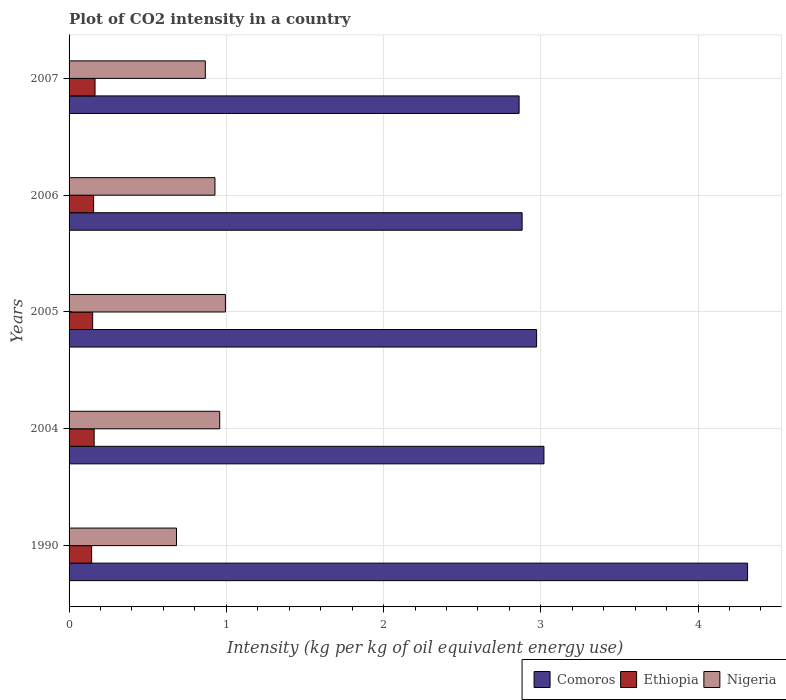How many different coloured bars are there?
Keep it short and to the point. 3. How many groups of bars are there?
Give a very brief answer. 5. Are the number of bars on each tick of the Y-axis equal?
Your answer should be compact. Yes. How many bars are there on the 1st tick from the top?
Your answer should be very brief. 3. How many bars are there on the 1st tick from the bottom?
Your answer should be compact. 3. In how many cases, is the number of bars for a given year not equal to the number of legend labels?
Keep it short and to the point. 0. What is the CO2 intensity in in Nigeria in 1990?
Provide a short and direct response. 0.68. Across all years, what is the maximum CO2 intensity in in Nigeria?
Offer a terse response. 0.99. Across all years, what is the minimum CO2 intensity in in Comoros?
Your answer should be compact. 2.86. In which year was the CO2 intensity in in Ethiopia maximum?
Give a very brief answer. 2007. What is the total CO2 intensity in in Comoros in the graph?
Make the answer very short. 16.05. What is the difference between the CO2 intensity in in Ethiopia in 1990 and that in 2006?
Your answer should be very brief. -0.01. What is the difference between the CO2 intensity in in Nigeria in 1990 and the CO2 intensity in in Ethiopia in 2005?
Provide a short and direct response. 0.53. What is the average CO2 intensity in in Ethiopia per year?
Make the answer very short. 0.15. In the year 2005, what is the difference between the CO2 intensity in in Nigeria and CO2 intensity in in Comoros?
Offer a very short reply. -1.98. In how many years, is the CO2 intensity in in Nigeria greater than 1 kg?
Provide a succinct answer. 0. What is the ratio of the CO2 intensity in in Comoros in 1990 to that in 2007?
Your response must be concise. 1.51. Is the difference between the CO2 intensity in in Nigeria in 1990 and 2006 greater than the difference between the CO2 intensity in in Comoros in 1990 and 2006?
Ensure brevity in your answer.  No. What is the difference between the highest and the second highest CO2 intensity in in Comoros?
Give a very brief answer. 1.3. What is the difference between the highest and the lowest CO2 intensity in in Ethiopia?
Provide a short and direct response. 0.02. In how many years, is the CO2 intensity in in Comoros greater than the average CO2 intensity in in Comoros taken over all years?
Offer a very short reply. 1. What does the 1st bar from the top in 2004 represents?
Your answer should be compact. Nigeria. What does the 2nd bar from the bottom in 2007 represents?
Make the answer very short. Ethiopia. How many years are there in the graph?
Provide a short and direct response. 5. Does the graph contain any zero values?
Provide a short and direct response. No. Does the graph contain grids?
Ensure brevity in your answer.  Yes. Where does the legend appear in the graph?
Your answer should be very brief. Bottom right. How many legend labels are there?
Your answer should be very brief. 3. What is the title of the graph?
Your answer should be compact. Plot of CO2 intensity in a country. What is the label or title of the X-axis?
Provide a short and direct response. Intensity (kg per kg of oil equivalent energy use). What is the Intensity (kg per kg of oil equivalent energy use) of Comoros in 1990?
Provide a short and direct response. 4.31. What is the Intensity (kg per kg of oil equivalent energy use) in Ethiopia in 1990?
Your answer should be very brief. 0.14. What is the Intensity (kg per kg of oil equivalent energy use) in Nigeria in 1990?
Ensure brevity in your answer.  0.68. What is the Intensity (kg per kg of oil equivalent energy use) of Comoros in 2004?
Give a very brief answer. 3.02. What is the Intensity (kg per kg of oil equivalent energy use) of Ethiopia in 2004?
Your answer should be compact. 0.16. What is the Intensity (kg per kg of oil equivalent energy use) of Nigeria in 2004?
Make the answer very short. 0.96. What is the Intensity (kg per kg of oil equivalent energy use) in Comoros in 2005?
Provide a succinct answer. 2.97. What is the Intensity (kg per kg of oil equivalent energy use) in Ethiopia in 2005?
Your answer should be compact. 0.15. What is the Intensity (kg per kg of oil equivalent energy use) of Nigeria in 2005?
Offer a very short reply. 0.99. What is the Intensity (kg per kg of oil equivalent energy use) of Comoros in 2006?
Ensure brevity in your answer.  2.88. What is the Intensity (kg per kg of oil equivalent energy use) in Ethiopia in 2006?
Your answer should be compact. 0.16. What is the Intensity (kg per kg of oil equivalent energy use) in Nigeria in 2006?
Offer a very short reply. 0.93. What is the Intensity (kg per kg of oil equivalent energy use) of Comoros in 2007?
Offer a terse response. 2.86. What is the Intensity (kg per kg of oil equivalent energy use) in Ethiopia in 2007?
Provide a short and direct response. 0.17. What is the Intensity (kg per kg of oil equivalent energy use) in Nigeria in 2007?
Your answer should be very brief. 0.87. Across all years, what is the maximum Intensity (kg per kg of oil equivalent energy use) of Comoros?
Keep it short and to the point. 4.31. Across all years, what is the maximum Intensity (kg per kg of oil equivalent energy use) of Ethiopia?
Provide a succinct answer. 0.17. Across all years, what is the maximum Intensity (kg per kg of oil equivalent energy use) in Nigeria?
Ensure brevity in your answer.  0.99. Across all years, what is the minimum Intensity (kg per kg of oil equivalent energy use) of Comoros?
Offer a very short reply. 2.86. Across all years, what is the minimum Intensity (kg per kg of oil equivalent energy use) in Ethiopia?
Keep it short and to the point. 0.14. Across all years, what is the minimum Intensity (kg per kg of oil equivalent energy use) of Nigeria?
Give a very brief answer. 0.68. What is the total Intensity (kg per kg of oil equivalent energy use) in Comoros in the graph?
Your answer should be very brief. 16.05. What is the total Intensity (kg per kg of oil equivalent energy use) of Ethiopia in the graph?
Offer a very short reply. 0.77. What is the total Intensity (kg per kg of oil equivalent energy use) in Nigeria in the graph?
Ensure brevity in your answer.  4.43. What is the difference between the Intensity (kg per kg of oil equivalent energy use) of Comoros in 1990 and that in 2004?
Offer a terse response. 1.29. What is the difference between the Intensity (kg per kg of oil equivalent energy use) of Ethiopia in 1990 and that in 2004?
Provide a succinct answer. -0.02. What is the difference between the Intensity (kg per kg of oil equivalent energy use) in Nigeria in 1990 and that in 2004?
Provide a succinct answer. -0.27. What is the difference between the Intensity (kg per kg of oil equivalent energy use) of Comoros in 1990 and that in 2005?
Give a very brief answer. 1.34. What is the difference between the Intensity (kg per kg of oil equivalent energy use) in Ethiopia in 1990 and that in 2005?
Offer a terse response. -0.01. What is the difference between the Intensity (kg per kg of oil equivalent energy use) of Nigeria in 1990 and that in 2005?
Ensure brevity in your answer.  -0.31. What is the difference between the Intensity (kg per kg of oil equivalent energy use) in Comoros in 1990 and that in 2006?
Your answer should be compact. 1.43. What is the difference between the Intensity (kg per kg of oil equivalent energy use) of Ethiopia in 1990 and that in 2006?
Your answer should be compact. -0.01. What is the difference between the Intensity (kg per kg of oil equivalent energy use) in Nigeria in 1990 and that in 2006?
Your answer should be very brief. -0.24. What is the difference between the Intensity (kg per kg of oil equivalent energy use) in Comoros in 1990 and that in 2007?
Make the answer very short. 1.45. What is the difference between the Intensity (kg per kg of oil equivalent energy use) of Ethiopia in 1990 and that in 2007?
Keep it short and to the point. -0.02. What is the difference between the Intensity (kg per kg of oil equivalent energy use) of Nigeria in 1990 and that in 2007?
Your response must be concise. -0.18. What is the difference between the Intensity (kg per kg of oil equivalent energy use) of Comoros in 2004 and that in 2005?
Give a very brief answer. 0.05. What is the difference between the Intensity (kg per kg of oil equivalent energy use) of Ethiopia in 2004 and that in 2005?
Give a very brief answer. 0.01. What is the difference between the Intensity (kg per kg of oil equivalent energy use) in Nigeria in 2004 and that in 2005?
Offer a terse response. -0.04. What is the difference between the Intensity (kg per kg of oil equivalent energy use) of Comoros in 2004 and that in 2006?
Your answer should be compact. 0.14. What is the difference between the Intensity (kg per kg of oil equivalent energy use) of Ethiopia in 2004 and that in 2006?
Give a very brief answer. 0. What is the difference between the Intensity (kg per kg of oil equivalent energy use) of Nigeria in 2004 and that in 2006?
Give a very brief answer. 0.03. What is the difference between the Intensity (kg per kg of oil equivalent energy use) of Comoros in 2004 and that in 2007?
Offer a terse response. 0.16. What is the difference between the Intensity (kg per kg of oil equivalent energy use) in Ethiopia in 2004 and that in 2007?
Keep it short and to the point. -0.01. What is the difference between the Intensity (kg per kg of oil equivalent energy use) of Nigeria in 2004 and that in 2007?
Ensure brevity in your answer.  0.09. What is the difference between the Intensity (kg per kg of oil equivalent energy use) in Comoros in 2005 and that in 2006?
Offer a very short reply. 0.09. What is the difference between the Intensity (kg per kg of oil equivalent energy use) in Ethiopia in 2005 and that in 2006?
Provide a short and direct response. -0.01. What is the difference between the Intensity (kg per kg of oil equivalent energy use) of Nigeria in 2005 and that in 2006?
Offer a very short reply. 0.07. What is the difference between the Intensity (kg per kg of oil equivalent energy use) in Comoros in 2005 and that in 2007?
Offer a terse response. 0.11. What is the difference between the Intensity (kg per kg of oil equivalent energy use) of Ethiopia in 2005 and that in 2007?
Provide a succinct answer. -0.02. What is the difference between the Intensity (kg per kg of oil equivalent energy use) in Nigeria in 2005 and that in 2007?
Provide a short and direct response. 0.13. What is the difference between the Intensity (kg per kg of oil equivalent energy use) in Comoros in 2006 and that in 2007?
Offer a very short reply. 0.02. What is the difference between the Intensity (kg per kg of oil equivalent energy use) of Ethiopia in 2006 and that in 2007?
Provide a short and direct response. -0.01. What is the difference between the Intensity (kg per kg of oil equivalent energy use) in Nigeria in 2006 and that in 2007?
Ensure brevity in your answer.  0.06. What is the difference between the Intensity (kg per kg of oil equivalent energy use) of Comoros in 1990 and the Intensity (kg per kg of oil equivalent energy use) of Ethiopia in 2004?
Give a very brief answer. 4.16. What is the difference between the Intensity (kg per kg of oil equivalent energy use) of Comoros in 1990 and the Intensity (kg per kg of oil equivalent energy use) of Nigeria in 2004?
Your answer should be compact. 3.36. What is the difference between the Intensity (kg per kg of oil equivalent energy use) in Ethiopia in 1990 and the Intensity (kg per kg of oil equivalent energy use) in Nigeria in 2004?
Offer a terse response. -0.81. What is the difference between the Intensity (kg per kg of oil equivalent energy use) of Comoros in 1990 and the Intensity (kg per kg of oil equivalent energy use) of Ethiopia in 2005?
Your answer should be compact. 4.16. What is the difference between the Intensity (kg per kg of oil equivalent energy use) of Comoros in 1990 and the Intensity (kg per kg of oil equivalent energy use) of Nigeria in 2005?
Give a very brief answer. 3.32. What is the difference between the Intensity (kg per kg of oil equivalent energy use) in Ethiopia in 1990 and the Intensity (kg per kg of oil equivalent energy use) in Nigeria in 2005?
Offer a terse response. -0.85. What is the difference between the Intensity (kg per kg of oil equivalent energy use) in Comoros in 1990 and the Intensity (kg per kg of oil equivalent energy use) in Ethiopia in 2006?
Keep it short and to the point. 4.16. What is the difference between the Intensity (kg per kg of oil equivalent energy use) of Comoros in 1990 and the Intensity (kg per kg of oil equivalent energy use) of Nigeria in 2006?
Your answer should be very brief. 3.39. What is the difference between the Intensity (kg per kg of oil equivalent energy use) in Ethiopia in 1990 and the Intensity (kg per kg of oil equivalent energy use) in Nigeria in 2006?
Provide a short and direct response. -0.78. What is the difference between the Intensity (kg per kg of oil equivalent energy use) of Comoros in 1990 and the Intensity (kg per kg of oil equivalent energy use) of Ethiopia in 2007?
Your answer should be very brief. 4.15. What is the difference between the Intensity (kg per kg of oil equivalent energy use) of Comoros in 1990 and the Intensity (kg per kg of oil equivalent energy use) of Nigeria in 2007?
Ensure brevity in your answer.  3.45. What is the difference between the Intensity (kg per kg of oil equivalent energy use) of Ethiopia in 1990 and the Intensity (kg per kg of oil equivalent energy use) of Nigeria in 2007?
Offer a terse response. -0.72. What is the difference between the Intensity (kg per kg of oil equivalent energy use) of Comoros in 2004 and the Intensity (kg per kg of oil equivalent energy use) of Ethiopia in 2005?
Keep it short and to the point. 2.87. What is the difference between the Intensity (kg per kg of oil equivalent energy use) of Comoros in 2004 and the Intensity (kg per kg of oil equivalent energy use) of Nigeria in 2005?
Give a very brief answer. 2.03. What is the difference between the Intensity (kg per kg of oil equivalent energy use) in Ethiopia in 2004 and the Intensity (kg per kg of oil equivalent energy use) in Nigeria in 2005?
Offer a terse response. -0.83. What is the difference between the Intensity (kg per kg of oil equivalent energy use) of Comoros in 2004 and the Intensity (kg per kg of oil equivalent energy use) of Ethiopia in 2006?
Provide a short and direct response. 2.86. What is the difference between the Intensity (kg per kg of oil equivalent energy use) of Comoros in 2004 and the Intensity (kg per kg of oil equivalent energy use) of Nigeria in 2006?
Provide a short and direct response. 2.09. What is the difference between the Intensity (kg per kg of oil equivalent energy use) of Ethiopia in 2004 and the Intensity (kg per kg of oil equivalent energy use) of Nigeria in 2006?
Offer a very short reply. -0.77. What is the difference between the Intensity (kg per kg of oil equivalent energy use) in Comoros in 2004 and the Intensity (kg per kg of oil equivalent energy use) in Ethiopia in 2007?
Make the answer very short. 2.85. What is the difference between the Intensity (kg per kg of oil equivalent energy use) in Comoros in 2004 and the Intensity (kg per kg of oil equivalent energy use) in Nigeria in 2007?
Keep it short and to the point. 2.15. What is the difference between the Intensity (kg per kg of oil equivalent energy use) of Ethiopia in 2004 and the Intensity (kg per kg of oil equivalent energy use) of Nigeria in 2007?
Provide a short and direct response. -0.71. What is the difference between the Intensity (kg per kg of oil equivalent energy use) in Comoros in 2005 and the Intensity (kg per kg of oil equivalent energy use) in Ethiopia in 2006?
Provide a short and direct response. 2.82. What is the difference between the Intensity (kg per kg of oil equivalent energy use) in Comoros in 2005 and the Intensity (kg per kg of oil equivalent energy use) in Nigeria in 2006?
Your answer should be very brief. 2.05. What is the difference between the Intensity (kg per kg of oil equivalent energy use) in Ethiopia in 2005 and the Intensity (kg per kg of oil equivalent energy use) in Nigeria in 2006?
Your response must be concise. -0.78. What is the difference between the Intensity (kg per kg of oil equivalent energy use) of Comoros in 2005 and the Intensity (kg per kg of oil equivalent energy use) of Ethiopia in 2007?
Give a very brief answer. 2.81. What is the difference between the Intensity (kg per kg of oil equivalent energy use) in Comoros in 2005 and the Intensity (kg per kg of oil equivalent energy use) in Nigeria in 2007?
Offer a very short reply. 2.11. What is the difference between the Intensity (kg per kg of oil equivalent energy use) of Ethiopia in 2005 and the Intensity (kg per kg of oil equivalent energy use) of Nigeria in 2007?
Keep it short and to the point. -0.72. What is the difference between the Intensity (kg per kg of oil equivalent energy use) in Comoros in 2006 and the Intensity (kg per kg of oil equivalent energy use) in Ethiopia in 2007?
Your response must be concise. 2.72. What is the difference between the Intensity (kg per kg of oil equivalent energy use) of Comoros in 2006 and the Intensity (kg per kg of oil equivalent energy use) of Nigeria in 2007?
Keep it short and to the point. 2.01. What is the difference between the Intensity (kg per kg of oil equivalent energy use) of Ethiopia in 2006 and the Intensity (kg per kg of oil equivalent energy use) of Nigeria in 2007?
Keep it short and to the point. -0.71. What is the average Intensity (kg per kg of oil equivalent energy use) of Comoros per year?
Make the answer very short. 3.21. What is the average Intensity (kg per kg of oil equivalent energy use) in Ethiopia per year?
Offer a very short reply. 0.15. What is the average Intensity (kg per kg of oil equivalent energy use) in Nigeria per year?
Your answer should be compact. 0.89. In the year 1990, what is the difference between the Intensity (kg per kg of oil equivalent energy use) in Comoros and Intensity (kg per kg of oil equivalent energy use) in Ethiopia?
Offer a terse response. 4.17. In the year 1990, what is the difference between the Intensity (kg per kg of oil equivalent energy use) of Comoros and Intensity (kg per kg of oil equivalent energy use) of Nigeria?
Ensure brevity in your answer.  3.63. In the year 1990, what is the difference between the Intensity (kg per kg of oil equivalent energy use) of Ethiopia and Intensity (kg per kg of oil equivalent energy use) of Nigeria?
Make the answer very short. -0.54. In the year 2004, what is the difference between the Intensity (kg per kg of oil equivalent energy use) in Comoros and Intensity (kg per kg of oil equivalent energy use) in Ethiopia?
Give a very brief answer. 2.86. In the year 2004, what is the difference between the Intensity (kg per kg of oil equivalent energy use) in Comoros and Intensity (kg per kg of oil equivalent energy use) in Nigeria?
Your answer should be compact. 2.06. In the year 2004, what is the difference between the Intensity (kg per kg of oil equivalent energy use) in Ethiopia and Intensity (kg per kg of oil equivalent energy use) in Nigeria?
Make the answer very short. -0.8. In the year 2005, what is the difference between the Intensity (kg per kg of oil equivalent energy use) in Comoros and Intensity (kg per kg of oil equivalent energy use) in Ethiopia?
Give a very brief answer. 2.82. In the year 2005, what is the difference between the Intensity (kg per kg of oil equivalent energy use) of Comoros and Intensity (kg per kg of oil equivalent energy use) of Nigeria?
Make the answer very short. 1.98. In the year 2005, what is the difference between the Intensity (kg per kg of oil equivalent energy use) of Ethiopia and Intensity (kg per kg of oil equivalent energy use) of Nigeria?
Make the answer very short. -0.84. In the year 2006, what is the difference between the Intensity (kg per kg of oil equivalent energy use) in Comoros and Intensity (kg per kg of oil equivalent energy use) in Ethiopia?
Your response must be concise. 2.73. In the year 2006, what is the difference between the Intensity (kg per kg of oil equivalent energy use) of Comoros and Intensity (kg per kg of oil equivalent energy use) of Nigeria?
Give a very brief answer. 1.95. In the year 2006, what is the difference between the Intensity (kg per kg of oil equivalent energy use) of Ethiopia and Intensity (kg per kg of oil equivalent energy use) of Nigeria?
Your answer should be very brief. -0.77. In the year 2007, what is the difference between the Intensity (kg per kg of oil equivalent energy use) of Comoros and Intensity (kg per kg of oil equivalent energy use) of Ethiopia?
Your answer should be very brief. 2.7. In the year 2007, what is the difference between the Intensity (kg per kg of oil equivalent energy use) of Comoros and Intensity (kg per kg of oil equivalent energy use) of Nigeria?
Make the answer very short. 2. In the year 2007, what is the difference between the Intensity (kg per kg of oil equivalent energy use) in Ethiopia and Intensity (kg per kg of oil equivalent energy use) in Nigeria?
Your answer should be compact. -0.7. What is the ratio of the Intensity (kg per kg of oil equivalent energy use) of Comoros in 1990 to that in 2004?
Your response must be concise. 1.43. What is the ratio of the Intensity (kg per kg of oil equivalent energy use) in Ethiopia in 1990 to that in 2004?
Keep it short and to the point. 0.9. What is the ratio of the Intensity (kg per kg of oil equivalent energy use) of Nigeria in 1990 to that in 2004?
Provide a short and direct response. 0.71. What is the ratio of the Intensity (kg per kg of oil equivalent energy use) in Comoros in 1990 to that in 2005?
Provide a succinct answer. 1.45. What is the ratio of the Intensity (kg per kg of oil equivalent energy use) of Ethiopia in 1990 to that in 2005?
Make the answer very short. 0.96. What is the ratio of the Intensity (kg per kg of oil equivalent energy use) of Nigeria in 1990 to that in 2005?
Ensure brevity in your answer.  0.69. What is the ratio of the Intensity (kg per kg of oil equivalent energy use) in Comoros in 1990 to that in 2006?
Your response must be concise. 1.5. What is the ratio of the Intensity (kg per kg of oil equivalent energy use) in Ethiopia in 1990 to that in 2006?
Your response must be concise. 0.92. What is the ratio of the Intensity (kg per kg of oil equivalent energy use) of Nigeria in 1990 to that in 2006?
Make the answer very short. 0.74. What is the ratio of the Intensity (kg per kg of oil equivalent energy use) in Comoros in 1990 to that in 2007?
Keep it short and to the point. 1.51. What is the ratio of the Intensity (kg per kg of oil equivalent energy use) in Ethiopia in 1990 to that in 2007?
Your response must be concise. 0.87. What is the ratio of the Intensity (kg per kg of oil equivalent energy use) in Nigeria in 1990 to that in 2007?
Your answer should be very brief. 0.79. What is the ratio of the Intensity (kg per kg of oil equivalent energy use) of Comoros in 2004 to that in 2005?
Offer a very short reply. 1.02. What is the ratio of the Intensity (kg per kg of oil equivalent energy use) in Ethiopia in 2004 to that in 2005?
Your response must be concise. 1.06. What is the ratio of the Intensity (kg per kg of oil equivalent energy use) in Nigeria in 2004 to that in 2005?
Ensure brevity in your answer.  0.96. What is the ratio of the Intensity (kg per kg of oil equivalent energy use) in Comoros in 2004 to that in 2006?
Provide a short and direct response. 1.05. What is the ratio of the Intensity (kg per kg of oil equivalent energy use) of Ethiopia in 2004 to that in 2006?
Your response must be concise. 1.02. What is the ratio of the Intensity (kg per kg of oil equivalent energy use) in Nigeria in 2004 to that in 2006?
Your answer should be very brief. 1.03. What is the ratio of the Intensity (kg per kg of oil equivalent energy use) in Comoros in 2004 to that in 2007?
Your response must be concise. 1.06. What is the ratio of the Intensity (kg per kg of oil equivalent energy use) of Ethiopia in 2004 to that in 2007?
Give a very brief answer. 0.97. What is the ratio of the Intensity (kg per kg of oil equivalent energy use) in Nigeria in 2004 to that in 2007?
Your response must be concise. 1.11. What is the ratio of the Intensity (kg per kg of oil equivalent energy use) in Comoros in 2005 to that in 2006?
Ensure brevity in your answer.  1.03. What is the ratio of the Intensity (kg per kg of oil equivalent energy use) in Ethiopia in 2005 to that in 2006?
Your answer should be very brief. 0.96. What is the ratio of the Intensity (kg per kg of oil equivalent energy use) of Nigeria in 2005 to that in 2006?
Give a very brief answer. 1.07. What is the ratio of the Intensity (kg per kg of oil equivalent energy use) of Comoros in 2005 to that in 2007?
Offer a terse response. 1.04. What is the ratio of the Intensity (kg per kg of oil equivalent energy use) of Ethiopia in 2005 to that in 2007?
Provide a succinct answer. 0.91. What is the ratio of the Intensity (kg per kg of oil equivalent energy use) of Nigeria in 2005 to that in 2007?
Provide a succinct answer. 1.15. What is the ratio of the Intensity (kg per kg of oil equivalent energy use) of Comoros in 2006 to that in 2007?
Offer a terse response. 1.01. What is the ratio of the Intensity (kg per kg of oil equivalent energy use) of Ethiopia in 2006 to that in 2007?
Your answer should be compact. 0.95. What is the ratio of the Intensity (kg per kg of oil equivalent energy use) in Nigeria in 2006 to that in 2007?
Give a very brief answer. 1.07. What is the difference between the highest and the second highest Intensity (kg per kg of oil equivalent energy use) in Comoros?
Offer a very short reply. 1.29. What is the difference between the highest and the second highest Intensity (kg per kg of oil equivalent energy use) of Ethiopia?
Provide a succinct answer. 0.01. What is the difference between the highest and the second highest Intensity (kg per kg of oil equivalent energy use) of Nigeria?
Make the answer very short. 0.04. What is the difference between the highest and the lowest Intensity (kg per kg of oil equivalent energy use) of Comoros?
Keep it short and to the point. 1.45. What is the difference between the highest and the lowest Intensity (kg per kg of oil equivalent energy use) in Ethiopia?
Keep it short and to the point. 0.02. What is the difference between the highest and the lowest Intensity (kg per kg of oil equivalent energy use) in Nigeria?
Your response must be concise. 0.31. 